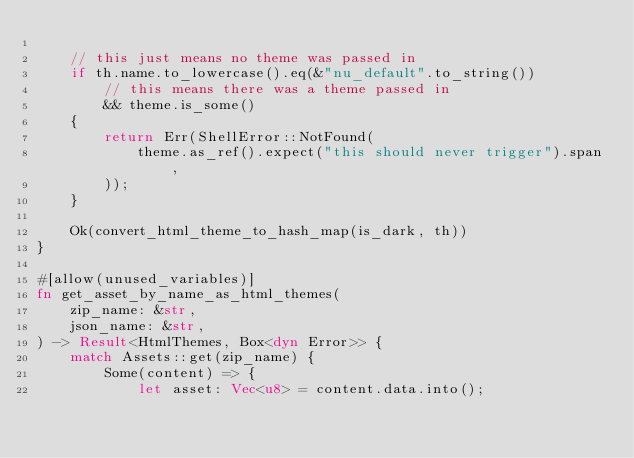Convert code to text. <code><loc_0><loc_0><loc_500><loc_500><_Rust_>
    // this just means no theme was passed in
    if th.name.to_lowercase().eq(&"nu_default".to_string())
        // this means there was a theme passed in
        && theme.is_some()
    {
        return Err(ShellError::NotFound(
            theme.as_ref().expect("this should never trigger").span,
        ));
    }

    Ok(convert_html_theme_to_hash_map(is_dark, th))
}

#[allow(unused_variables)]
fn get_asset_by_name_as_html_themes(
    zip_name: &str,
    json_name: &str,
) -> Result<HtmlThemes, Box<dyn Error>> {
    match Assets::get(zip_name) {
        Some(content) => {
            let asset: Vec<u8> = content.data.into();</code> 